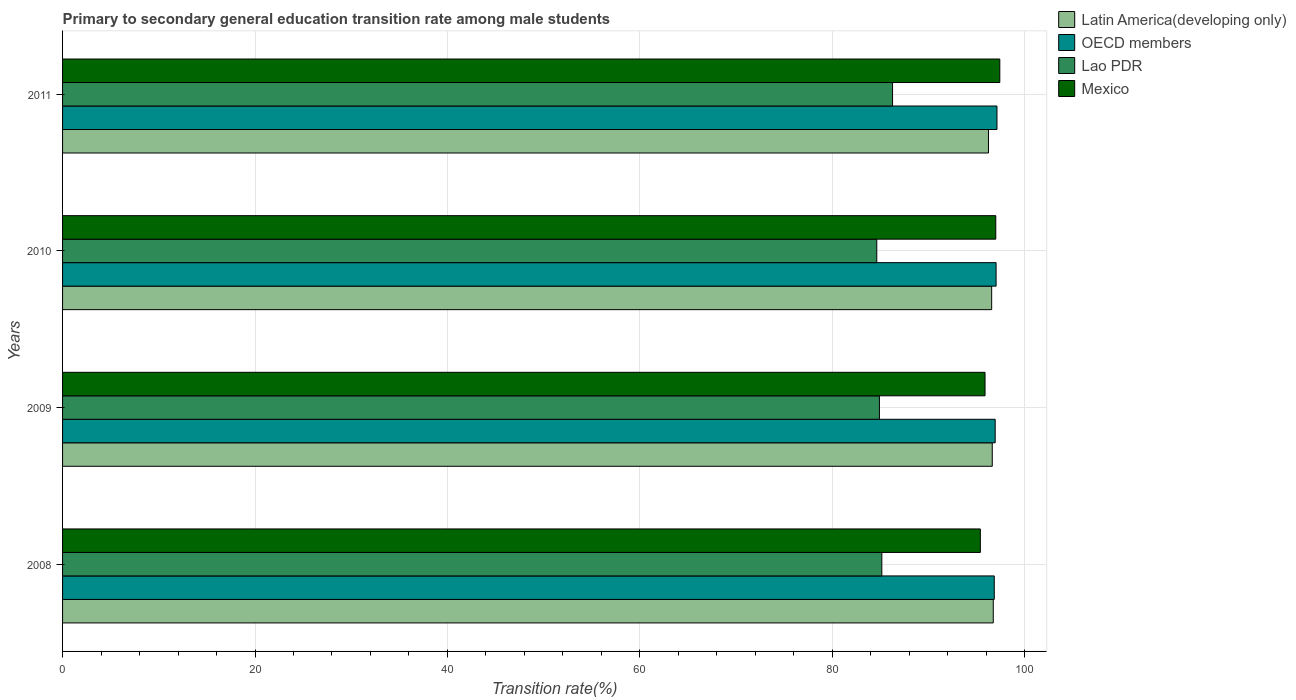How many different coloured bars are there?
Ensure brevity in your answer.  4. How many groups of bars are there?
Ensure brevity in your answer.  4. Are the number of bars per tick equal to the number of legend labels?
Give a very brief answer. Yes. How many bars are there on the 3rd tick from the top?
Your response must be concise. 4. What is the transition rate in OECD members in 2011?
Give a very brief answer. 97.11. Across all years, what is the maximum transition rate in Mexico?
Your answer should be compact. 97.41. Across all years, what is the minimum transition rate in Lao PDR?
Offer a terse response. 84.62. What is the total transition rate in Lao PDR in the graph?
Give a very brief answer. 340.92. What is the difference between the transition rate in Latin America(developing only) in 2010 and that in 2011?
Offer a terse response. 0.33. What is the difference between the transition rate in Mexico in 2009 and the transition rate in OECD members in 2008?
Provide a short and direct response. -0.96. What is the average transition rate in Lao PDR per year?
Ensure brevity in your answer.  85.23. In the year 2011, what is the difference between the transition rate in Mexico and transition rate in Latin America(developing only)?
Ensure brevity in your answer.  1.18. What is the ratio of the transition rate in Mexico in 2010 to that in 2011?
Your response must be concise. 1. What is the difference between the highest and the second highest transition rate in Latin America(developing only)?
Provide a short and direct response. 0.1. What is the difference between the highest and the lowest transition rate in Latin America(developing only)?
Offer a terse response. 0.5. In how many years, is the transition rate in Lao PDR greater than the average transition rate in Lao PDR taken over all years?
Your answer should be very brief. 1. Is the sum of the transition rate in Mexico in 2009 and 2011 greater than the maximum transition rate in OECD members across all years?
Your response must be concise. Yes. Is it the case that in every year, the sum of the transition rate in Latin America(developing only) and transition rate in OECD members is greater than the sum of transition rate in Lao PDR and transition rate in Mexico?
Offer a terse response. No. What does the 1st bar from the bottom in 2011 represents?
Your answer should be very brief. Latin America(developing only). How many bars are there?
Offer a very short reply. 16. Are all the bars in the graph horizontal?
Give a very brief answer. Yes. What is the difference between two consecutive major ticks on the X-axis?
Your response must be concise. 20. Are the values on the major ticks of X-axis written in scientific E-notation?
Make the answer very short. No. Does the graph contain grids?
Your answer should be compact. Yes. Where does the legend appear in the graph?
Your response must be concise. Top right. What is the title of the graph?
Provide a succinct answer. Primary to secondary general education transition rate among male students. Does "Portugal" appear as one of the legend labels in the graph?
Your answer should be very brief. No. What is the label or title of the X-axis?
Keep it short and to the point. Transition rate(%). What is the label or title of the Y-axis?
Keep it short and to the point. Years. What is the Transition rate(%) of Latin America(developing only) in 2008?
Your response must be concise. 96.73. What is the Transition rate(%) in OECD members in 2008?
Give a very brief answer. 96.83. What is the Transition rate(%) of Lao PDR in 2008?
Offer a terse response. 85.15. What is the Transition rate(%) in Mexico in 2008?
Provide a short and direct response. 95.38. What is the Transition rate(%) in Latin America(developing only) in 2009?
Provide a succinct answer. 96.62. What is the Transition rate(%) of OECD members in 2009?
Offer a very short reply. 96.93. What is the Transition rate(%) in Lao PDR in 2009?
Your answer should be very brief. 84.9. What is the Transition rate(%) of Mexico in 2009?
Give a very brief answer. 95.87. What is the Transition rate(%) of Latin America(developing only) in 2010?
Offer a terse response. 96.56. What is the Transition rate(%) in OECD members in 2010?
Ensure brevity in your answer.  97.02. What is the Transition rate(%) in Lao PDR in 2010?
Provide a short and direct response. 84.62. What is the Transition rate(%) of Mexico in 2010?
Make the answer very short. 96.99. What is the Transition rate(%) of Latin America(developing only) in 2011?
Your response must be concise. 96.23. What is the Transition rate(%) in OECD members in 2011?
Offer a terse response. 97.11. What is the Transition rate(%) of Lao PDR in 2011?
Ensure brevity in your answer.  86.26. What is the Transition rate(%) of Mexico in 2011?
Provide a succinct answer. 97.41. Across all years, what is the maximum Transition rate(%) of Latin America(developing only)?
Give a very brief answer. 96.73. Across all years, what is the maximum Transition rate(%) of OECD members?
Make the answer very short. 97.11. Across all years, what is the maximum Transition rate(%) of Lao PDR?
Offer a very short reply. 86.26. Across all years, what is the maximum Transition rate(%) of Mexico?
Give a very brief answer. 97.41. Across all years, what is the minimum Transition rate(%) of Latin America(developing only)?
Provide a short and direct response. 96.23. Across all years, what is the minimum Transition rate(%) of OECD members?
Provide a short and direct response. 96.83. Across all years, what is the minimum Transition rate(%) of Lao PDR?
Offer a terse response. 84.62. Across all years, what is the minimum Transition rate(%) in Mexico?
Provide a short and direct response. 95.38. What is the total Transition rate(%) in Latin America(developing only) in the graph?
Offer a very short reply. 386.14. What is the total Transition rate(%) of OECD members in the graph?
Offer a terse response. 387.89. What is the total Transition rate(%) of Lao PDR in the graph?
Offer a terse response. 340.92. What is the total Transition rate(%) in Mexico in the graph?
Your answer should be compact. 385.65. What is the difference between the Transition rate(%) in Latin America(developing only) in 2008 and that in 2009?
Your response must be concise. 0.1. What is the difference between the Transition rate(%) in OECD members in 2008 and that in 2009?
Keep it short and to the point. -0.1. What is the difference between the Transition rate(%) in Lao PDR in 2008 and that in 2009?
Provide a short and direct response. 0.25. What is the difference between the Transition rate(%) in Mexico in 2008 and that in 2009?
Your answer should be compact. -0.49. What is the difference between the Transition rate(%) of Latin America(developing only) in 2008 and that in 2010?
Make the answer very short. 0.17. What is the difference between the Transition rate(%) of OECD members in 2008 and that in 2010?
Offer a terse response. -0.19. What is the difference between the Transition rate(%) of Lao PDR in 2008 and that in 2010?
Keep it short and to the point. 0.52. What is the difference between the Transition rate(%) in Mexico in 2008 and that in 2010?
Keep it short and to the point. -1.6. What is the difference between the Transition rate(%) in Latin America(developing only) in 2008 and that in 2011?
Your answer should be compact. 0.5. What is the difference between the Transition rate(%) in OECD members in 2008 and that in 2011?
Your response must be concise. -0.28. What is the difference between the Transition rate(%) of Lao PDR in 2008 and that in 2011?
Keep it short and to the point. -1.11. What is the difference between the Transition rate(%) in Mexico in 2008 and that in 2011?
Ensure brevity in your answer.  -2.02. What is the difference between the Transition rate(%) in Latin America(developing only) in 2009 and that in 2010?
Ensure brevity in your answer.  0.06. What is the difference between the Transition rate(%) of OECD members in 2009 and that in 2010?
Offer a terse response. -0.09. What is the difference between the Transition rate(%) of Lao PDR in 2009 and that in 2010?
Your answer should be very brief. 0.27. What is the difference between the Transition rate(%) in Mexico in 2009 and that in 2010?
Your response must be concise. -1.12. What is the difference between the Transition rate(%) in Latin America(developing only) in 2009 and that in 2011?
Offer a very short reply. 0.39. What is the difference between the Transition rate(%) in OECD members in 2009 and that in 2011?
Offer a terse response. -0.19. What is the difference between the Transition rate(%) in Lao PDR in 2009 and that in 2011?
Ensure brevity in your answer.  -1.36. What is the difference between the Transition rate(%) in Mexico in 2009 and that in 2011?
Ensure brevity in your answer.  -1.54. What is the difference between the Transition rate(%) of Latin America(developing only) in 2010 and that in 2011?
Make the answer very short. 0.33. What is the difference between the Transition rate(%) in OECD members in 2010 and that in 2011?
Keep it short and to the point. -0.09. What is the difference between the Transition rate(%) in Lao PDR in 2010 and that in 2011?
Your response must be concise. -1.64. What is the difference between the Transition rate(%) of Mexico in 2010 and that in 2011?
Ensure brevity in your answer.  -0.42. What is the difference between the Transition rate(%) of Latin America(developing only) in 2008 and the Transition rate(%) of OECD members in 2009?
Your answer should be compact. -0.2. What is the difference between the Transition rate(%) of Latin America(developing only) in 2008 and the Transition rate(%) of Lao PDR in 2009?
Offer a very short reply. 11.83. What is the difference between the Transition rate(%) in Latin America(developing only) in 2008 and the Transition rate(%) in Mexico in 2009?
Provide a succinct answer. 0.86. What is the difference between the Transition rate(%) of OECD members in 2008 and the Transition rate(%) of Lao PDR in 2009?
Ensure brevity in your answer.  11.94. What is the difference between the Transition rate(%) in OECD members in 2008 and the Transition rate(%) in Mexico in 2009?
Ensure brevity in your answer.  0.96. What is the difference between the Transition rate(%) of Lao PDR in 2008 and the Transition rate(%) of Mexico in 2009?
Provide a short and direct response. -10.73. What is the difference between the Transition rate(%) of Latin America(developing only) in 2008 and the Transition rate(%) of OECD members in 2010?
Make the answer very short. -0.29. What is the difference between the Transition rate(%) of Latin America(developing only) in 2008 and the Transition rate(%) of Lao PDR in 2010?
Provide a short and direct response. 12.11. What is the difference between the Transition rate(%) of Latin America(developing only) in 2008 and the Transition rate(%) of Mexico in 2010?
Your response must be concise. -0.26. What is the difference between the Transition rate(%) in OECD members in 2008 and the Transition rate(%) in Lao PDR in 2010?
Ensure brevity in your answer.  12.21. What is the difference between the Transition rate(%) in OECD members in 2008 and the Transition rate(%) in Mexico in 2010?
Make the answer very short. -0.16. What is the difference between the Transition rate(%) of Lao PDR in 2008 and the Transition rate(%) of Mexico in 2010?
Make the answer very short. -11.84. What is the difference between the Transition rate(%) in Latin America(developing only) in 2008 and the Transition rate(%) in OECD members in 2011?
Offer a terse response. -0.38. What is the difference between the Transition rate(%) of Latin America(developing only) in 2008 and the Transition rate(%) of Lao PDR in 2011?
Provide a short and direct response. 10.47. What is the difference between the Transition rate(%) of Latin America(developing only) in 2008 and the Transition rate(%) of Mexico in 2011?
Keep it short and to the point. -0.68. What is the difference between the Transition rate(%) of OECD members in 2008 and the Transition rate(%) of Lao PDR in 2011?
Ensure brevity in your answer.  10.57. What is the difference between the Transition rate(%) of OECD members in 2008 and the Transition rate(%) of Mexico in 2011?
Your answer should be compact. -0.58. What is the difference between the Transition rate(%) of Lao PDR in 2008 and the Transition rate(%) of Mexico in 2011?
Provide a short and direct response. -12.26. What is the difference between the Transition rate(%) of Latin America(developing only) in 2009 and the Transition rate(%) of OECD members in 2010?
Your answer should be very brief. -0.4. What is the difference between the Transition rate(%) of Latin America(developing only) in 2009 and the Transition rate(%) of Lao PDR in 2010?
Keep it short and to the point. 12. What is the difference between the Transition rate(%) in Latin America(developing only) in 2009 and the Transition rate(%) in Mexico in 2010?
Offer a terse response. -0.37. What is the difference between the Transition rate(%) of OECD members in 2009 and the Transition rate(%) of Lao PDR in 2010?
Provide a short and direct response. 12.3. What is the difference between the Transition rate(%) in OECD members in 2009 and the Transition rate(%) in Mexico in 2010?
Provide a short and direct response. -0.06. What is the difference between the Transition rate(%) of Lao PDR in 2009 and the Transition rate(%) of Mexico in 2010?
Your answer should be very brief. -12.09. What is the difference between the Transition rate(%) in Latin America(developing only) in 2009 and the Transition rate(%) in OECD members in 2011?
Give a very brief answer. -0.49. What is the difference between the Transition rate(%) in Latin America(developing only) in 2009 and the Transition rate(%) in Lao PDR in 2011?
Keep it short and to the point. 10.36. What is the difference between the Transition rate(%) of Latin America(developing only) in 2009 and the Transition rate(%) of Mexico in 2011?
Make the answer very short. -0.79. What is the difference between the Transition rate(%) of OECD members in 2009 and the Transition rate(%) of Lao PDR in 2011?
Ensure brevity in your answer.  10.67. What is the difference between the Transition rate(%) in OECD members in 2009 and the Transition rate(%) in Mexico in 2011?
Provide a short and direct response. -0.48. What is the difference between the Transition rate(%) of Lao PDR in 2009 and the Transition rate(%) of Mexico in 2011?
Ensure brevity in your answer.  -12.51. What is the difference between the Transition rate(%) of Latin America(developing only) in 2010 and the Transition rate(%) of OECD members in 2011?
Offer a terse response. -0.55. What is the difference between the Transition rate(%) of Latin America(developing only) in 2010 and the Transition rate(%) of Lao PDR in 2011?
Make the answer very short. 10.3. What is the difference between the Transition rate(%) of Latin America(developing only) in 2010 and the Transition rate(%) of Mexico in 2011?
Provide a short and direct response. -0.85. What is the difference between the Transition rate(%) of OECD members in 2010 and the Transition rate(%) of Lao PDR in 2011?
Your answer should be compact. 10.76. What is the difference between the Transition rate(%) of OECD members in 2010 and the Transition rate(%) of Mexico in 2011?
Keep it short and to the point. -0.39. What is the difference between the Transition rate(%) of Lao PDR in 2010 and the Transition rate(%) of Mexico in 2011?
Give a very brief answer. -12.79. What is the average Transition rate(%) in Latin America(developing only) per year?
Make the answer very short. 96.53. What is the average Transition rate(%) of OECD members per year?
Provide a short and direct response. 96.97. What is the average Transition rate(%) in Lao PDR per year?
Offer a terse response. 85.23. What is the average Transition rate(%) of Mexico per year?
Your answer should be very brief. 96.41. In the year 2008, what is the difference between the Transition rate(%) of Latin America(developing only) and Transition rate(%) of OECD members?
Your response must be concise. -0.1. In the year 2008, what is the difference between the Transition rate(%) in Latin America(developing only) and Transition rate(%) in Lao PDR?
Give a very brief answer. 11.58. In the year 2008, what is the difference between the Transition rate(%) in Latin America(developing only) and Transition rate(%) in Mexico?
Give a very brief answer. 1.34. In the year 2008, what is the difference between the Transition rate(%) in OECD members and Transition rate(%) in Lao PDR?
Keep it short and to the point. 11.69. In the year 2008, what is the difference between the Transition rate(%) in OECD members and Transition rate(%) in Mexico?
Keep it short and to the point. 1.45. In the year 2008, what is the difference between the Transition rate(%) in Lao PDR and Transition rate(%) in Mexico?
Offer a terse response. -10.24. In the year 2009, what is the difference between the Transition rate(%) of Latin America(developing only) and Transition rate(%) of OECD members?
Your answer should be compact. -0.3. In the year 2009, what is the difference between the Transition rate(%) of Latin America(developing only) and Transition rate(%) of Lao PDR?
Keep it short and to the point. 11.73. In the year 2009, what is the difference between the Transition rate(%) of Latin America(developing only) and Transition rate(%) of Mexico?
Your answer should be compact. 0.75. In the year 2009, what is the difference between the Transition rate(%) in OECD members and Transition rate(%) in Lao PDR?
Provide a succinct answer. 12.03. In the year 2009, what is the difference between the Transition rate(%) of OECD members and Transition rate(%) of Mexico?
Your answer should be compact. 1.06. In the year 2009, what is the difference between the Transition rate(%) of Lao PDR and Transition rate(%) of Mexico?
Make the answer very short. -10.98. In the year 2010, what is the difference between the Transition rate(%) of Latin America(developing only) and Transition rate(%) of OECD members?
Offer a very short reply. -0.46. In the year 2010, what is the difference between the Transition rate(%) of Latin America(developing only) and Transition rate(%) of Lao PDR?
Ensure brevity in your answer.  11.94. In the year 2010, what is the difference between the Transition rate(%) of Latin America(developing only) and Transition rate(%) of Mexico?
Provide a succinct answer. -0.43. In the year 2010, what is the difference between the Transition rate(%) in OECD members and Transition rate(%) in Lao PDR?
Your answer should be very brief. 12.4. In the year 2010, what is the difference between the Transition rate(%) in OECD members and Transition rate(%) in Mexico?
Make the answer very short. 0.03. In the year 2010, what is the difference between the Transition rate(%) in Lao PDR and Transition rate(%) in Mexico?
Provide a short and direct response. -12.37. In the year 2011, what is the difference between the Transition rate(%) in Latin America(developing only) and Transition rate(%) in OECD members?
Provide a short and direct response. -0.88. In the year 2011, what is the difference between the Transition rate(%) of Latin America(developing only) and Transition rate(%) of Lao PDR?
Your response must be concise. 9.97. In the year 2011, what is the difference between the Transition rate(%) in Latin America(developing only) and Transition rate(%) in Mexico?
Offer a very short reply. -1.18. In the year 2011, what is the difference between the Transition rate(%) in OECD members and Transition rate(%) in Lao PDR?
Your response must be concise. 10.85. In the year 2011, what is the difference between the Transition rate(%) of OECD members and Transition rate(%) of Mexico?
Your response must be concise. -0.3. In the year 2011, what is the difference between the Transition rate(%) in Lao PDR and Transition rate(%) in Mexico?
Keep it short and to the point. -11.15. What is the ratio of the Transition rate(%) in Latin America(developing only) in 2008 to that in 2009?
Offer a very short reply. 1. What is the ratio of the Transition rate(%) in Lao PDR in 2008 to that in 2009?
Provide a short and direct response. 1. What is the ratio of the Transition rate(%) in Mexico in 2008 to that in 2010?
Give a very brief answer. 0.98. What is the ratio of the Transition rate(%) in Latin America(developing only) in 2008 to that in 2011?
Make the answer very short. 1.01. What is the ratio of the Transition rate(%) in Lao PDR in 2008 to that in 2011?
Your response must be concise. 0.99. What is the ratio of the Transition rate(%) in Mexico in 2008 to that in 2011?
Keep it short and to the point. 0.98. What is the ratio of the Transition rate(%) of Latin America(developing only) in 2009 to that in 2010?
Provide a short and direct response. 1. What is the ratio of the Transition rate(%) in OECD members in 2009 to that in 2010?
Your answer should be compact. 1. What is the ratio of the Transition rate(%) of Mexico in 2009 to that in 2010?
Provide a succinct answer. 0.99. What is the ratio of the Transition rate(%) in Latin America(developing only) in 2009 to that in 2011?
Your answer should be compact. 1. What is the ratio of the Transition rate(%) of OECD members in 2009 to that in 2011?
Give a very brief answer. 1. What is the ratio of the Transition rate(%) of Lao PDR in 2009 to that in 2011?
Offer a terse response. 0.98. What is the ratio of the Transition rate(%) of Mexico in 2009 to that in 2011?
Your response must be concise. 0.98. What is the ratio of the Transition rate(%) in Latin America(developing only) in 2010 to that in 2011?
Ensure brevity in your answer.  1. What is the ratio of the Transition rate(%) in Mexico in 2010 to that in 2011?
Provide a short and direct response. 1. What is the difference between the highest and the second highest Transition rate(%) of Latin America(developing only)?
Offer a terse response. 0.1. What is the difference between the highest and the second highest Transition rate(%) of OECD members?
Your answer should be compact. 0.09. What is the difference between the highest and the second highest Transition rate(%) in Lao PDR?
Ensure brevity in your answer.  1.11. What is the difference between the highest and the second highest Transition rate(%) of Mexico?
Your response must be concise. 0.42. What is the difference between the highest and the lowest Transition rate(%) of Latin America(developing only)?
Your answer should be very brief. 0.5. What is the difference between the highest and the lowest Transition rate(%) of OECD members?
Keep it short and to the point. 0.28. What is the difference between the highest and the lowest Transition rate(%) of Lao PDR?
Your answer should be very brief. 1.64. What is the difference between the highest and the lowest Transition rate(%) in Mexico?
Offer a very short reply. 2.02. 